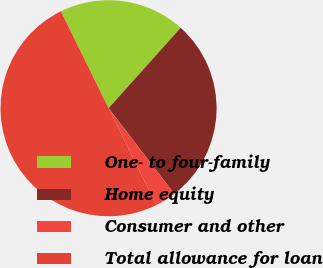Convert chart. <chart><loc_0><loc_0><loc_500><loc_500><pie_chart><fcel>One- to four-family<fcel>Home equity<fcel>Consumer and other<fcel>Total allowance for loan<nl><fcel>18.91%<fcel>27.93%<fcel>3.15%<fcel>50.0%<nl></chart> 